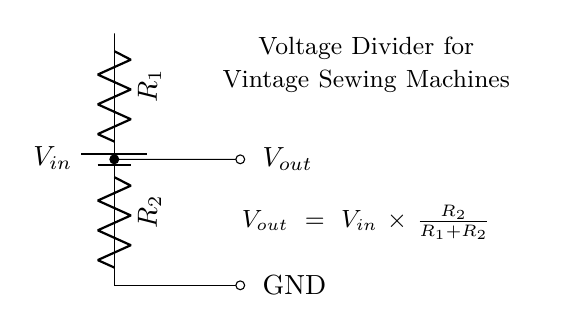What is the input voltage in this circuit? The input voltage is represented as \( V_{in} \), indicated by the battery symbol in the diagram. The battery provides the power to the circuit.
Answer: \( V_{in} \) What are the resistance values in this voltage divider? The circuit shows two resistors labeled \( R_1 \) and \( R_2 \). These resistors are used to divide the voltage supplied from \( V_{in} \) to \( V_{out} \).
Answer: \( R_1 \), \( R_2 \) What is the formula for calculating output voltage? The diagram provides the formula \( V_{out} = V_{in} \times \frac{R_2}{R_1 + R_2} \) directly below the circuit. This formula illustrates how the output voltage depends on the input voltage and the resistor values.
Answer: \( V_{out} \) How does the output voltage relate to the resistors? The output voltage \( V_{out} \) is directly proportional to \( R_2 \) and inversely proportional to the sum of \( R_1 \) and \( R_2 \). This means that as \( R_2 \) increases relative to \( R_1 \), \( V_{out} \) increases.
Answer: Proportional What happens if \( R_1 \) is much larger than \( R_2 \)? If \( R_1 \) is significantly larger than \( R_2 \), then \( V_{out} \) will be a small percentage of \( V_{in} \). Since most of the voltage drop occurs over \( R_1 \), \( V_{out} \) will be very low.
Answer: Low output What is the function of this circuit in vintage sewing machines? The voltage divider circuit regulates the voltage supplied to vintage sewing machines, ensuring that the components receive the proper voltage for their operation without damage.
Answer: Voltage regulation 